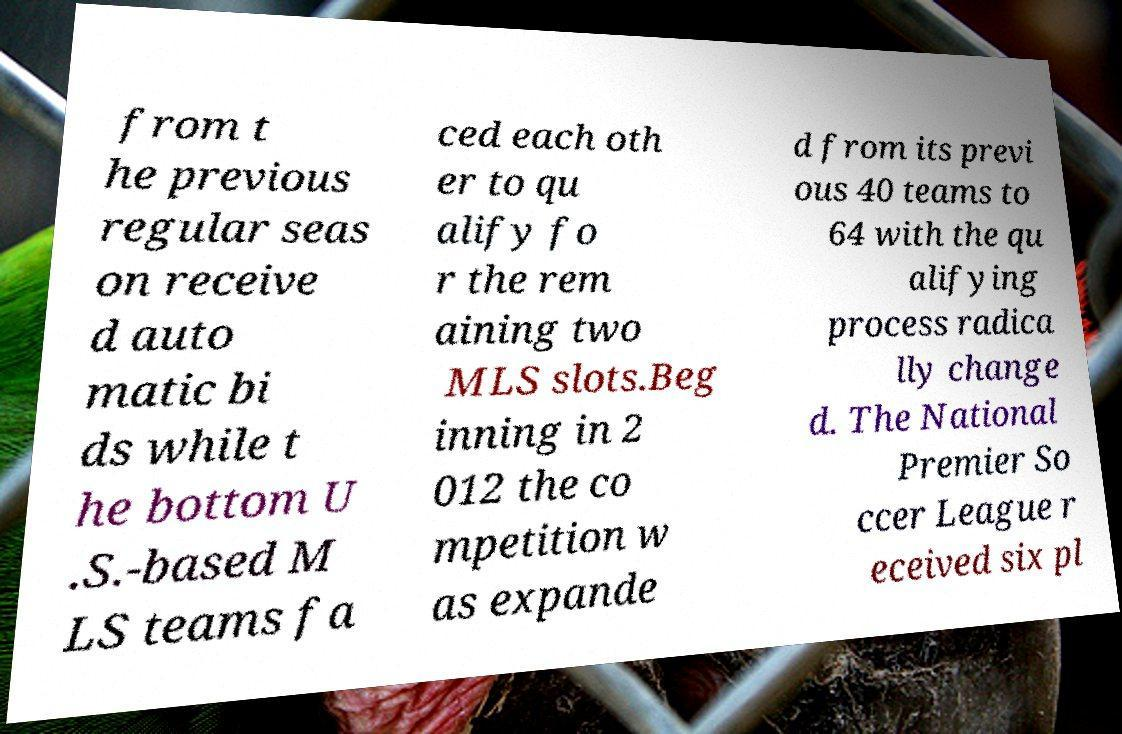Please read and relay the text visible in this image. What does it say? from t he previous regular seas on receive d auto matic bi ds while t he bottom U .S.-based M LS teams fa ced each oth er to qu alify fo r the rem aining two MLS slots.Beg inning in 2 012 the co mpetition w as expande d from its previ ous 40 teams to 64 with the qu alifying process radica lly change d. The National Premier So ccer League r eceived six pl 